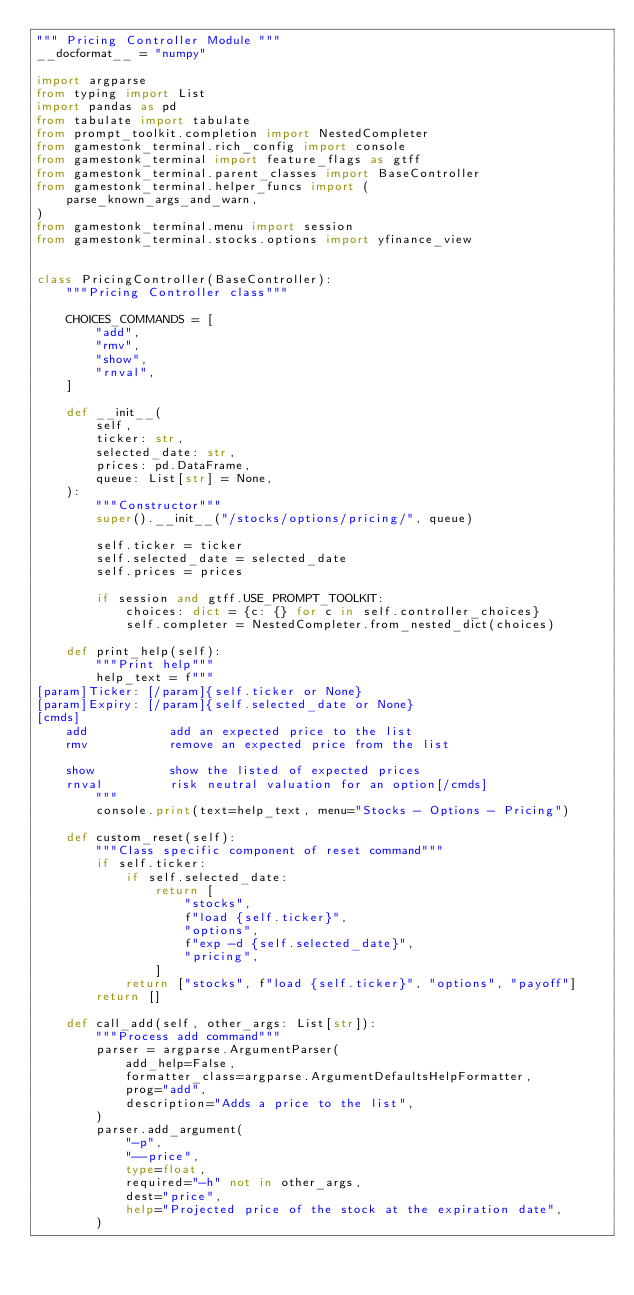<code> <loc_0><loc_0><loc_500><loc_500><_Python_>""" Pricing Controller Module """
__docformat__ = "numpy"

import argparse
from typing import List
import pandas as pd
from tabulate import tabulate
from prompt_toolkit.completion import NestedCompleter
from gamestonk_terminal.rich_config import console
from gamestonk_terminal import feature_flags as gtff
from gamestonk_terminal.parent_classes import BaseController
from gamestonk_terminal.helper_funcs import (
    parse_known_args_and_warn,
)
from gamestonk_terminal.menu import session
from gamestonk_terminal.stocks.options import yfinance_view


class PricingController(BaseController):
    """Pricing Controller class"""

    CHOICES_COMMANDS = [
        "add",
        "rmv",
        "show",
        "rnval",
    ]

    def __init__(
        self,
        ticker: str,
        selected_date: str,
        prices: pd.DataFrame,
        queue: List[str] = None,
    ):
        """Constructor"""
        super().__init__("/stocks/options/pricing/", queue)

        self.ticker = ticker
        self.selected_date = selected_date
        self.prices = prices

        if session and gtff.USE_PROMPT_TOOLKIT:
            choices: dict = {c: {} for c in self.controller_choices}
            self.completer = NestedCompleter.from_nested_dict(choices)

    def print_help(self):
        """Print help"""
        help_text = f"""
[param]Ticker: [/param]{self.ticker or None}
[param]Expiry: [/param]{self.selected_date or None}
[cmds]
    add           add an expected price to the list
    rmv           remove an expected price from the list

    show          show the listed of expected prices
    rnval         risk neutral valuation for an option[/cmds]
        """
        console.print(text=help_text, menu="Stocks - Options - Pricing")

    def custom_reset(self):
        """Class specific component of reset command"""
        if self.ticker:
            if self.selected_date:
                return [
                    "stocks",
                    f"load {self.ticker}",
                    "options",
                    f"exp -d {self.selected_date}",
                    "pricing",
                ]
            return ["stocks", f"load {self.ticker}", "options", "payoff"]
        return []

    def call_add(self, other_args: List[str]):
        """Process add command"""
        parser = argparse.ArgumentParser(
            add_help=False,
            formatter_class=argparse.ArgumentDefaultsHelpFormatter,
            prog="add",
            description="Adds a price to the list",
        )
        parser.add_argument(
            "-p",
            "--price",
            type=float,
            required="-h" not in other_args,
            dest="price",
            help="Projected price of the stock at the expiration date",
        )</code> 